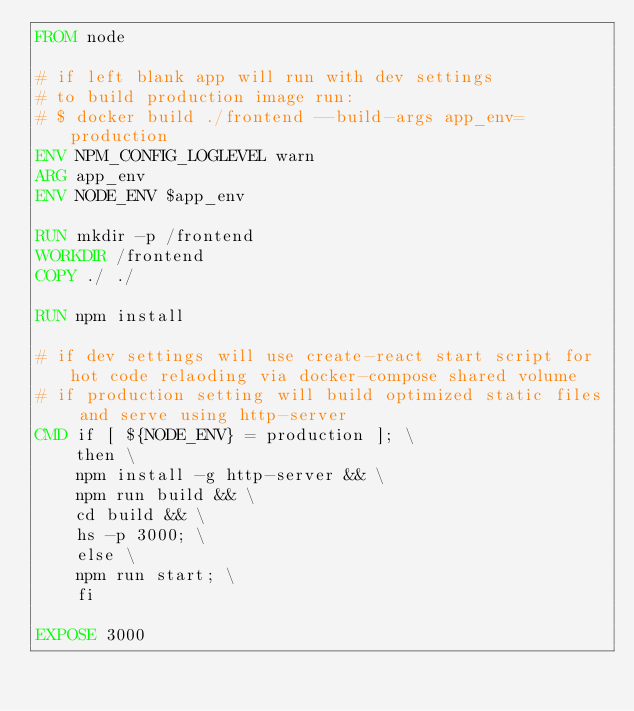<code> <loc_0><loc_0><loc_500><loc_500><_Dockerfile_>FROM node

# if left blank app will run with dev settings
# to build production image run:
# $ docker build ./frontend --build-args app_env=production
ENV NPM_CONFIG_LOGLEVEL warn
ARG app_env
ENV NODE_ENV $app_env

RUN mkdir -p /frontend
WORKDIR /frontend
COPY ./ ./

RUN npm install

# if dev settings will use create-react start script for hot code relaoding via docker-compose shared volume
# if production setting will build optimized static files and serve using http-server
CMD if [ ${NODE_ENV} = production ]; \
	then \
	npm install -g http-server && \
	npm run build && \
	cd build && \
	hs -p 3000; \
	else \
	npm run start; \
	fi

EXPOSE 3000
</code> 